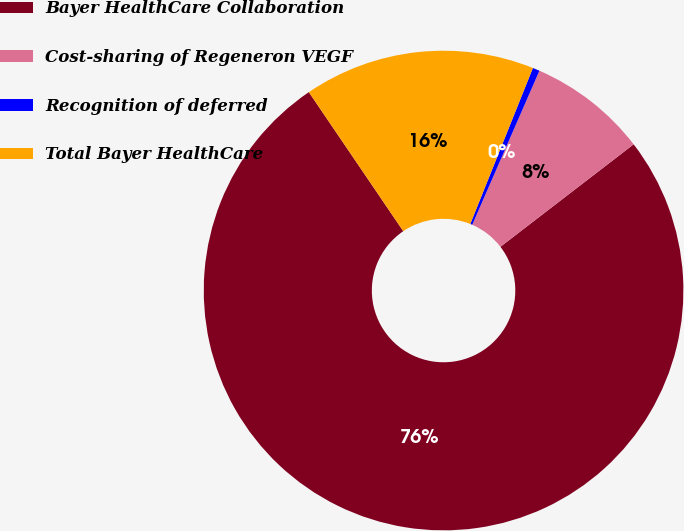Convert chart to OTSL. <chart><loc_0><loc_0><loc_500><loc_500><pie_chart><fcel>Bayer HealthCare Collaboration<fcel>Cost-sharing of Regeneron VEGF<fcel>Recognition of deferred<fcel>Total Bayer HealthCare<nl><fcel>75.95%<fcel>8.02%<fcel>0.47%<fcel>15.57%<nl></chart> 